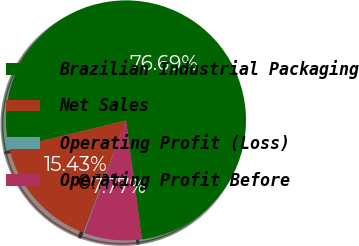Convert chart. <chart><loc_0><loc_0><loc_500><loc_500><pie_chart><fcel>Brazilian Industrial Packaging<fcel>Net Sales<fcel>Operating Profit (Loss)<fcel>Operating Profit Before<nl><fcel>76.69%<fcel>15.43%<fcel>0.11%<fcel>7.77%<nl></chart> 